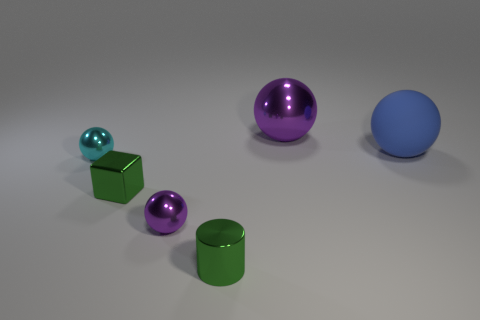There is a tiny cylinder that is the same color as the shiny block; what is it made of?
Offer a terse response. Metal. Are there any other things that are the same shape as the large blue object?
Ensure brevity in your answer.  Yes. How many things are either cyan objects or tiny purple shiny objects?
Offer a terse response. 2. What size is the cyan metal object that is the same shape as the rubber object?
Offer a very short reply. Small. Is there any other thing that is the same size as the cyan object?
Offer a terse response. Yes. How many other things are the same color as the block?
Ensure brevity in your answer.  1. What number of balls are either purple objects or large purple things?
Your answer should be very brief. 2. The thing to the right of the purple metallic object behind the big rubber object is what color?
Offer a terse response. Blue. What is the shape of the tiny purple metal object?
Provide a succinct answer. Sphere. Is the size of the purple ball in front of the cyan object the same as the big rubber ball?
Provide a short and direct response. No. 